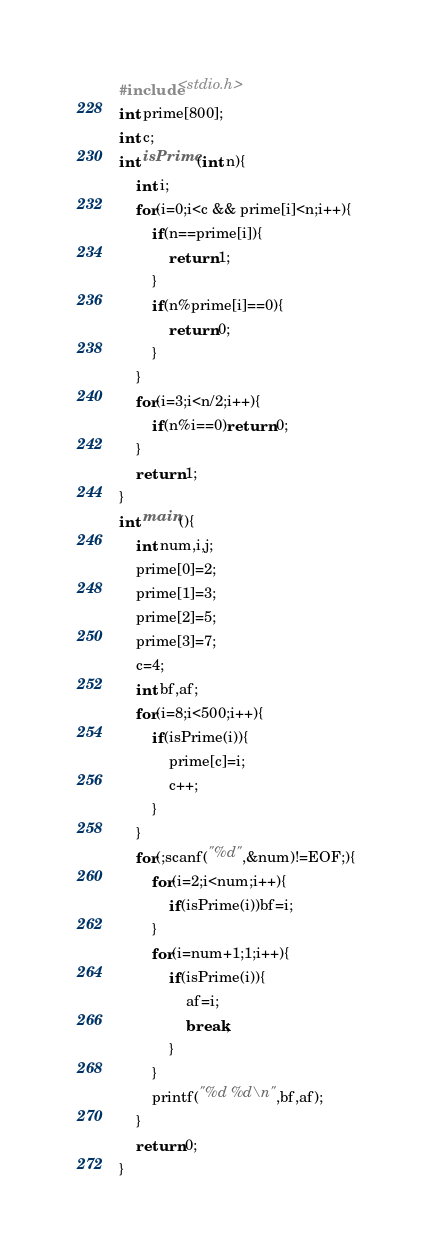Convert code to text. <code><loc_0><loc_0><loc_500><loc_500><_C_>#include<stdio.h>
int prime[800];
int c;
int isPrime(int n){
	int i;
	for(i=0;i<c && prime[i]<n;i++){
		if(n==prime[i]){
			return 1;
		}
		if(n%prime[i]==0){
			return 0;
		}
	}
	for(i=3;i<n/2;i++){
		if(n%i==0)return 0;
	}
	return 1;
}
int main(){
	int num,i,j;
	prime[0]=2;
	prime[1]=3;
	prime[2]=5;
	prime[3]=7;
	c=4;
	int bf,af;
	for(i=8;i<500;i++){
		if(isPrime(i)){
			prime[c]=i;
			c++;
		}
	}
	for(;scanf("%d",&num)!=EOF;){
		for(i=2;i<num;i++){
			if(isPrime(i))bf=i;
		}
		for(i=num+1;1;i++){
			if(isPrime(i)){
				af=i;
				break;
			}
		}
		printf("%d %d\n",bf,af);
	}
	return 0;
}</code> 